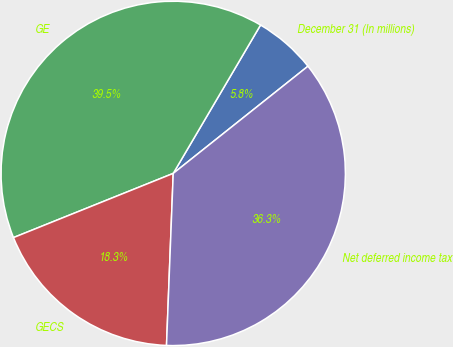Convert chart. <chart><loc_0><loc_0><loc_500><loc_500><pie_chart><fcel>December 31 (In millions)<fcel>GE<fcel>GECS<fcel>Net deferred income tax<nl><fcel>5.84%<fcel>39.55%<fcel>18.3%<fcel>36.32%<nl></chart> 